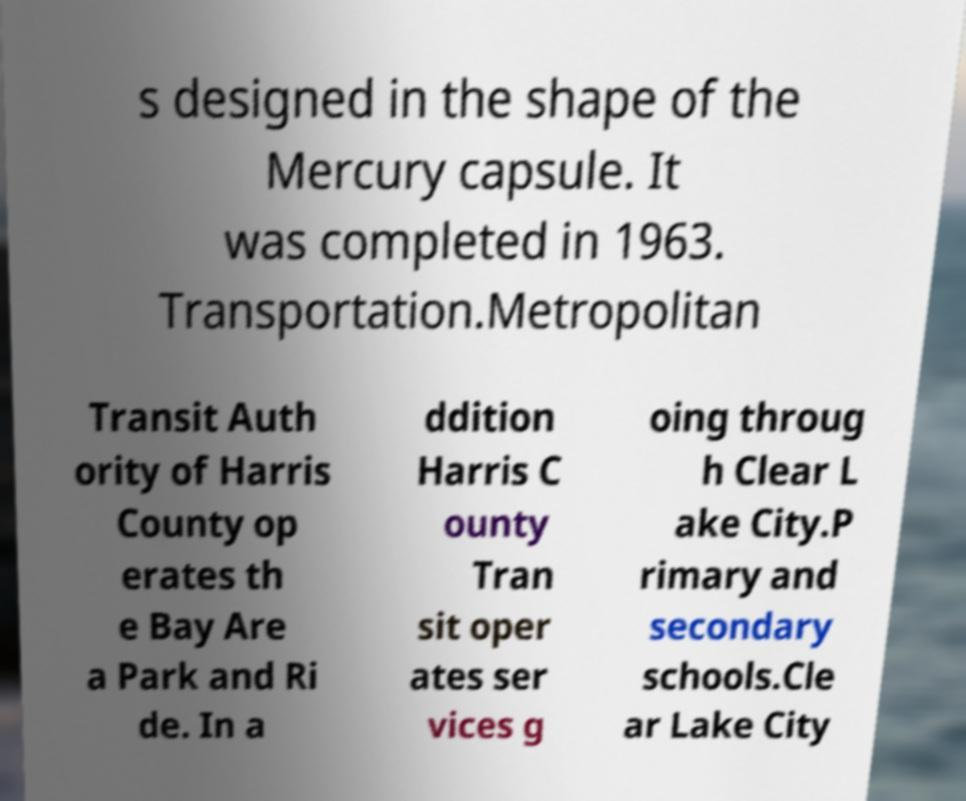I need the written content from this picture converted into text. Can you do that? s designed in the shape of the Mercury capsule. It was completed in 1963. Transportation.Metropolitan Transit Auth ority of Harris County op erates th e Bay Are a Park and Ri de. In a ddition Harris C ounty Tran sit oper ates ser vices g oing throug h Clear L ake City.P rimary and secondary schools.Cle ar Lake City 